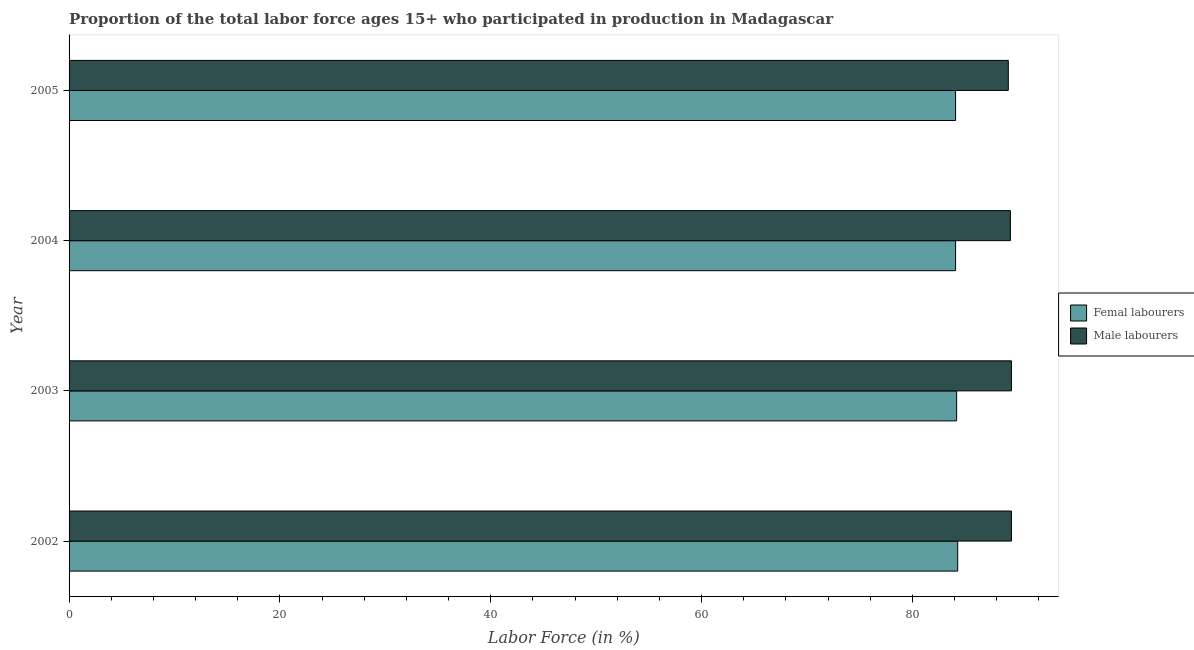How many groups of bars are there?
Ensure brevity in your answer.  4. How many bars are there on the 1st tick from the bottom?
Make the answer very short. 2. In how many cases, is the number of bars for a given year not equal to the number of legend labels?
Your answer should be compact. 0. What is the percentage of male labour force in 2004?
Your response must be concise. 89.3. Across all years, what is the maximum percentage of male labour force?
Make the answer very short. 89.4. Across all years, what is the minimum percentage of female labor force?
Your response must be concise. 84.1. In which year was the percentage of male labour force maximum?
Provide a succinct answer. 2002. What is the total percentage of female labor force in the graph?
Offer a very short reply. 336.7. What is the difference between the percentage of female labor force in 2003 and the percentage of male labour force in 2002?
Give a very brief answer. -5.2. What is the average percentage of female labor force per year?
Make the answer very short. 84.17. In how many years, is the percentage of female labor force greater than 60 %?
Your answer should be compact. 4. Is the percentage of female labor force in 2003 less than that in 2005?
Provide a short and direct response. No. What is the difference between the highest and the second highest percentage of female labor force?
Ensure brevity in your answer.  0.1. What is the difference between the highest and the lowest percentage of male labour force?
Your response must be concise. 0.3. Is the sum of the percentage of male labour force in 2002 and 2005 greater than the maximum percentage of female labor force across all years?
Provide a short and direct response. Yes. What does the 1st bar from the top in 2005 represents?
Your response must be concise. Male labourers. What does the 1st bar from the bottom in 2003 represents?
Offer a terse response. Femal labourers. How many bars are there?
Offer a terse response. 8. Are all the bars in the graph horizontal?
Make the answer very short. Yes. How many years are there in the graph?
Offer a very short reply. 4. Are the values on the major ticks of X-axis written in scientific E-notation?
Provide a succinct answer. No. Does the graph contain any zero values?
Keep it short and to the point. No. Where does the legend appear in the graph?
Your answer should be compact. Center right. How many legend labels are there?
Provide a succinct answer. 2. What is the title of the graph?
Give a very brief answer. Proportion of the total labor force ages 15+ who participated in production in Madagascar. Does "Secondary Education" appear as one of the legend labels in the graph?
Your answer should be very brief. No. What is the label or title of the X-axis?
Your answer should be compact. Labor Force (in %). What is the label or title of the Y-axis?
Provide a succinct answer. Year. What is the Labor Force (in %) in Femal labourers in 2002?
Ensure brevity in your answer.  84.3. What is the Labor Force (in %) of Male labourers in 2002?
Offer a terse response. 89.4. What is the Labor Force (in %) in Femal labourers in 2003?
Your answer should be very brief. 84.2. What is the Labor Force (in %) of Male labourers in 2003?
Offer a very short reply. 89.4. What is the Labor Force (in %) in Femal labourers in 2004?
Keep it short and to the point. 84.1. What is the Labor Force (in %) of Male labourers in 2004?
Provide a short and direct response. 89.3. What is the Labor Force (in %) of Femal labourers in 2005?
Your answer should be compact. 84.1. What is the Labor Force (in %) of Male labourers in 2005?
Keep it short and to the point. 89.1. Across all years, what is the maximum Labor Force (in %) in Femal labourers?
Offer a very short reply. 84.3. Across all years, what is the maximum Labor Force (in %) in Male labourers?
Make the answer very short. 89.4. Across all years, what is the minimum Labor Force (in %) of Femal labourers?
Offer a terse response. 84.1. Across all years, what is the minimum Labor Force (in %) in Male labourers?
Provide a succinct answer. 89.1. What is the total Labor Force (in %) of Femal labourers in the graph?
Give a very brief answer. 336.7. What is the total Labor Force (in %) in Male labourers in the graph?
Make the answer very short. 357.2. What is the difference between the Labor Force (in %) of Femal labourers in 2002 and that in 2003?
Your response must be concise. 0.1. What is the difference between the Labor Force (in %) in Femal labourers in 2002 and that in 2004?
Your response must be concise. 0.2. What is the difference between the Labor Force (in %) of Male labourers in 2002 and that in 2004?
Ensure brevity in your answer.  0.1. What is the difference between the Labor Force (in %) in Femal labourers in 2002 and that in 2005?
Offer a terse response. 0.2. What is the difference between the Labor Force (in %) in Male labourers in 2002 and that in 2005?
Keep it short and to the point. 0.3. What is the difference between the Labor Force (in %) in Male labourers in 2003 and that in 2004?
Offer a terse response. 0.1. What is the difference between the Labor Force (in %) of Femal labourers in 2003 and that in 2005?
Your answer should be very brief. 0.1. What is the difference between the Labor Force (in %) in Male labourers in 2004 and that in 2005?
Keep it short and to the point. 0.2. What is the difference between the Labor Force (in %) in Femal labourers in 2002 and the Labor Force (in %) in Male labourers in 2003?
Make the answer very short. -5.1. What is the difference between the Labor Force (in %) in Femal labourers in 2002 and the Labor Force (in %) in Male labourers in 2004?
Provide a succinct answer. -5. What is the difference between the Labor Force (in %) in Femal labourers in 2003 and the Labor Force (in %) in Male labourers in 2004?
Your response must be concise. -5.1. What is the average Labor Force (in %) of Femal labourers per year?
Ensure brevity in your answer.  84.17. What is the average Labor Force (in %) of Male labourers per year?
Keep it short and to the point. 89.3. In the year 2002, what is the difference between the Labor Force (in %) in Femal labourers and Labor Force (in %) in Male labourers?
Offer a terse response. -5.1. In the year 2005, what is the difference between the Labor Force (in %) in Femal labourers and Labor Force (in %) in Male labourers?
Ensure brevity in your answer.  -5. What is the ratio of the Labor Force (in %) in Male labourers in 2002 to that in 2003?
Keep it short and to the point. 1. What is the ratio of the Labor Force (in %) in Male labourers in 2002 to that in 2004?
Make the answer very short. 1. What is the ratio of the Labor Force (in %) in Male labourers in 2002 to that in 2005?
Your response must be concise. 1. What is the ratio of the Labor Force (in %) of Male labourers in 2003 to that in 2004?
Your answer should be compact. 1. What is the ratio of the Labor Force (in %) of Femal labourers in 2003 to that in 2005?
Ensure brevity in your answer.  1. What is the ratio of the Labor Force (in %) of Femal labourers in 2004 to that in 2005?
Provide a succinct answer. 1. What is the ratio of the Labor Force (in %) in Male labourers in 2004 to that in 2005?
Your answer should be compact. 1. What is the difference between the highest and the second highest Labor Force (in %) in Femal labourers?
Offer a very short reply. 0.1. What is the difference between the highest and the lowest Labor Force (in %) of Male labourers?
Provide a short and direct response. 0.3. 